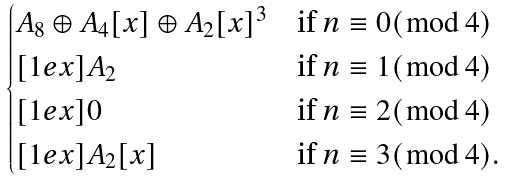Convert formula to latex. <formula><loc_0><loc_0><loc_500><loc_500>\begin{cases} A _ { 8 } \oplus A _ { 4 } [ x ] \oplus A _ { 2 } [ x ] ^ { 3 } & \text {if $n\equiv 0(\bmod\, 4)$} \\ [ 1 e x ] A _ { 2 } & \text {if $n\equiv 1(\bmod\, 4)$} \\ [ 1 e x ] 0 & \text {if $n\equiv 2(\bmod\, 4)$} \\ [ 1 e x ] A _ { 2 } [ x ] & \text {if $n\equiv 3(\bmod\, 4)$} . \end{cases}</formula> 